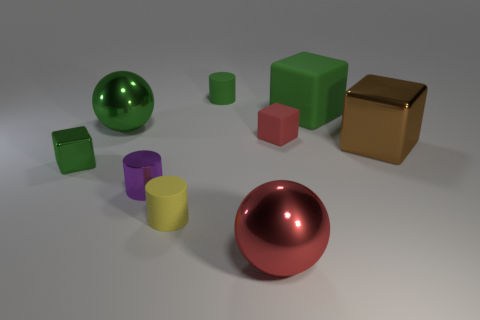Add 1 brown blocks. How many objects exist? 10 Subtract all cylinders. How many objects are left? 6 Subtract all large red metal balls. Subtract all tiny metal objects. How many objects are left? 6 Add 1 small yellow cylinders. How many small yellow cylinders are left? 2 Add 3 red spheres. How many red spheres exist? 4 Subtract 1 red spheres. How many objects are left? 8 